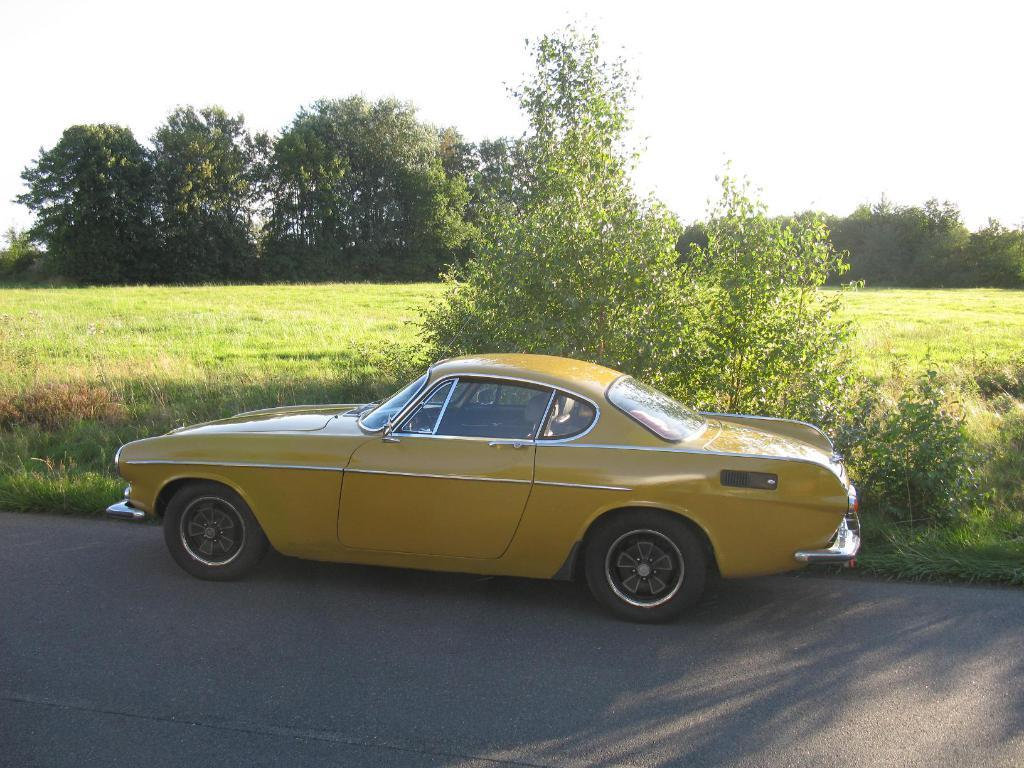What color is the car in the image? The car in the image is yellow. Where is the car located in the image? The car is on the road in the image. What type of vegetation can be seen on the ground? There are plants and grass on the ground in the image. What can be seen in the background of the image? There are trees and the sky visible in the background of the image. Can you tell me how many credit attempts the car has made in the image? There is no mention of credit or attempts in the image; it features a yellow car on the road with plants, trees, and the sky in the background. 